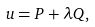<formula> <loc_0><loc_0><loc_500><loc_500>u = P + \lambda Q ,</formula> 